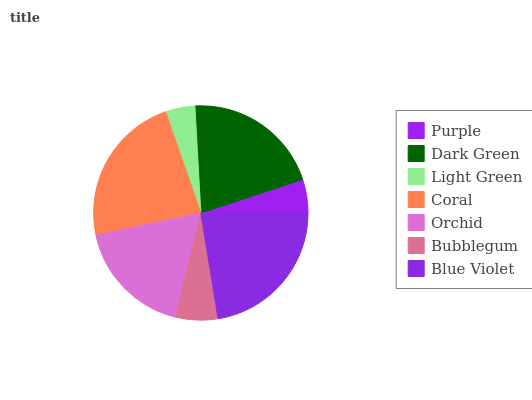Is Light Green the minimum?
Answer yes or no. Yes. Is Coral the maximum?
Answer yes or no. Yes. Is Dark Green the minimum?
Answer yes or no. No. Is Dark Green the maximum?
Answer yes or no. No. Is Dark Green greater than Purple?
Answer yes or no. Yes. Is Purple less than Dark Green?
Answer yes or no. Yes. Is Purple greater than Dark Green?
Answer yes or no. No. Is Dark Green less than Purple?
Answer yes or no. No. Is Orchid the high median?
Answer yes or no. Yes. Is Orchid the low median?
Answer yes or no. Yes. Is Blue Violet the high median?
Answer yes or no. No. Is Bubblegum the low median?
Answer yes or no. No. 